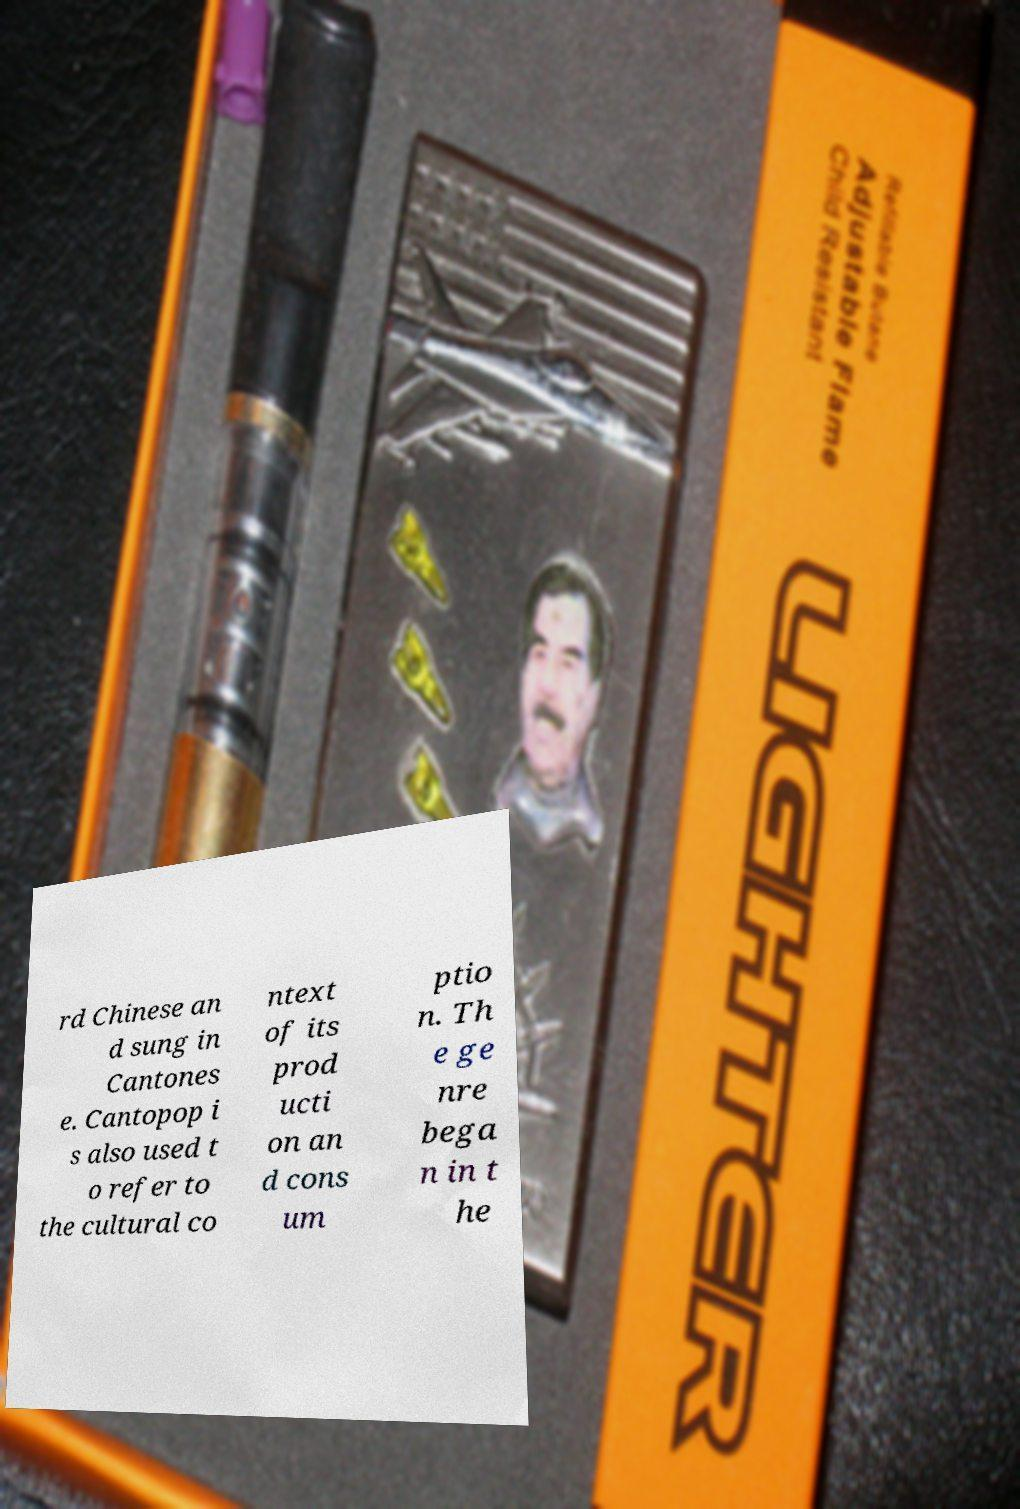For documentation purposes, I need the text within this image transcribed. Could you provide that? rd Chinese an d sung in Cantones e. Cantopop i s also used t o refer to the cultural co ntext of its prod ucti on an d cons um ptio n. Th e ge nre bega n in t he 